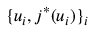Convert formula to latex. <formula><loc_0><loc_0><loc_500><loc_500>\{ u _ { i } , j ^ { * } ( u _ { i } ) \} _ { i }</formula> 